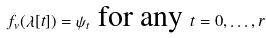Convert formula to latex. <formula><loc_0><loc_0><loc_500><loc_500>f _ { v } ( { \lambda } [ t ] ) = \psi _ { t } \text { for any } t = 0 , \dots , r</formula> 